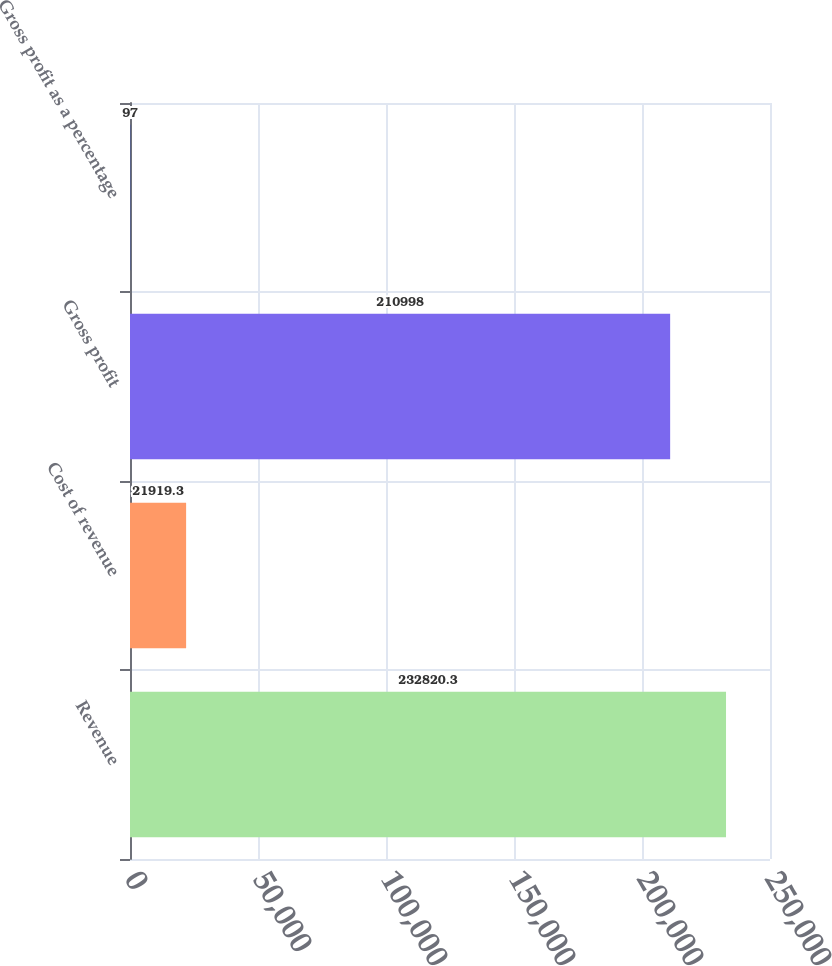Convert chart to OTSL. <chart><loc_0><loc_0><loc_500><loc_500><bar_chart><fcel>Revenue<fcel>Cost of revenue<fcel>Gross profit<fcel>Gross profit as a percentage<nl><fcel>232820<fcel>21919.3<fcel>210998<fcel>97<nl></chart> 